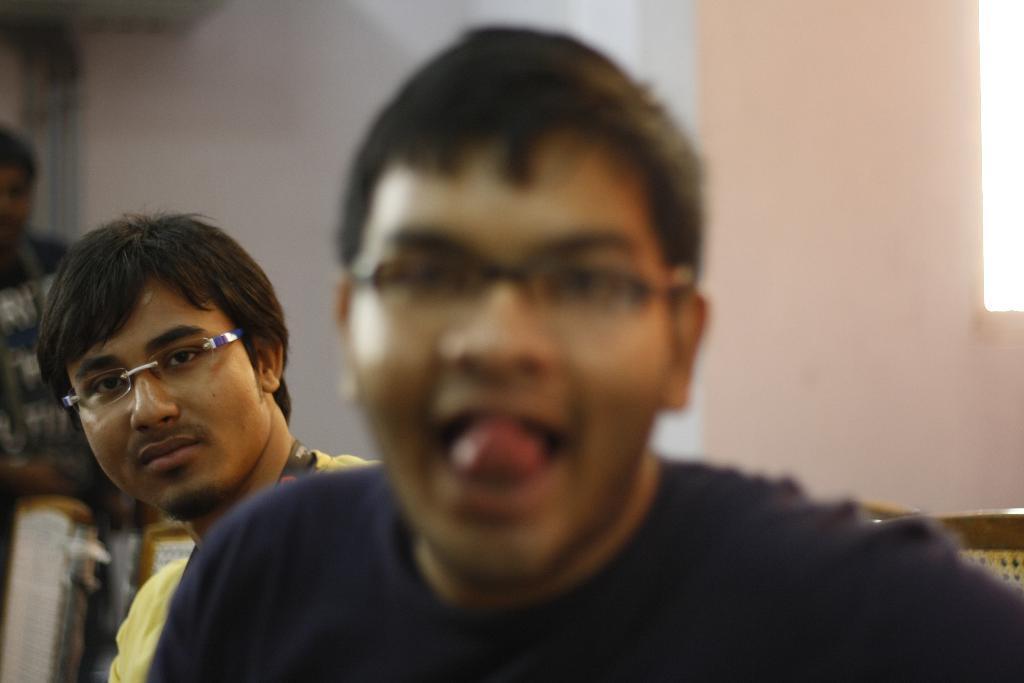In one or two sentences, can you explain what this image depicts? In this image in the center the are persons sitting on a chair. And the person in the front is sitting and having some expression on his face. In the background there is wall and there is a person standing. 